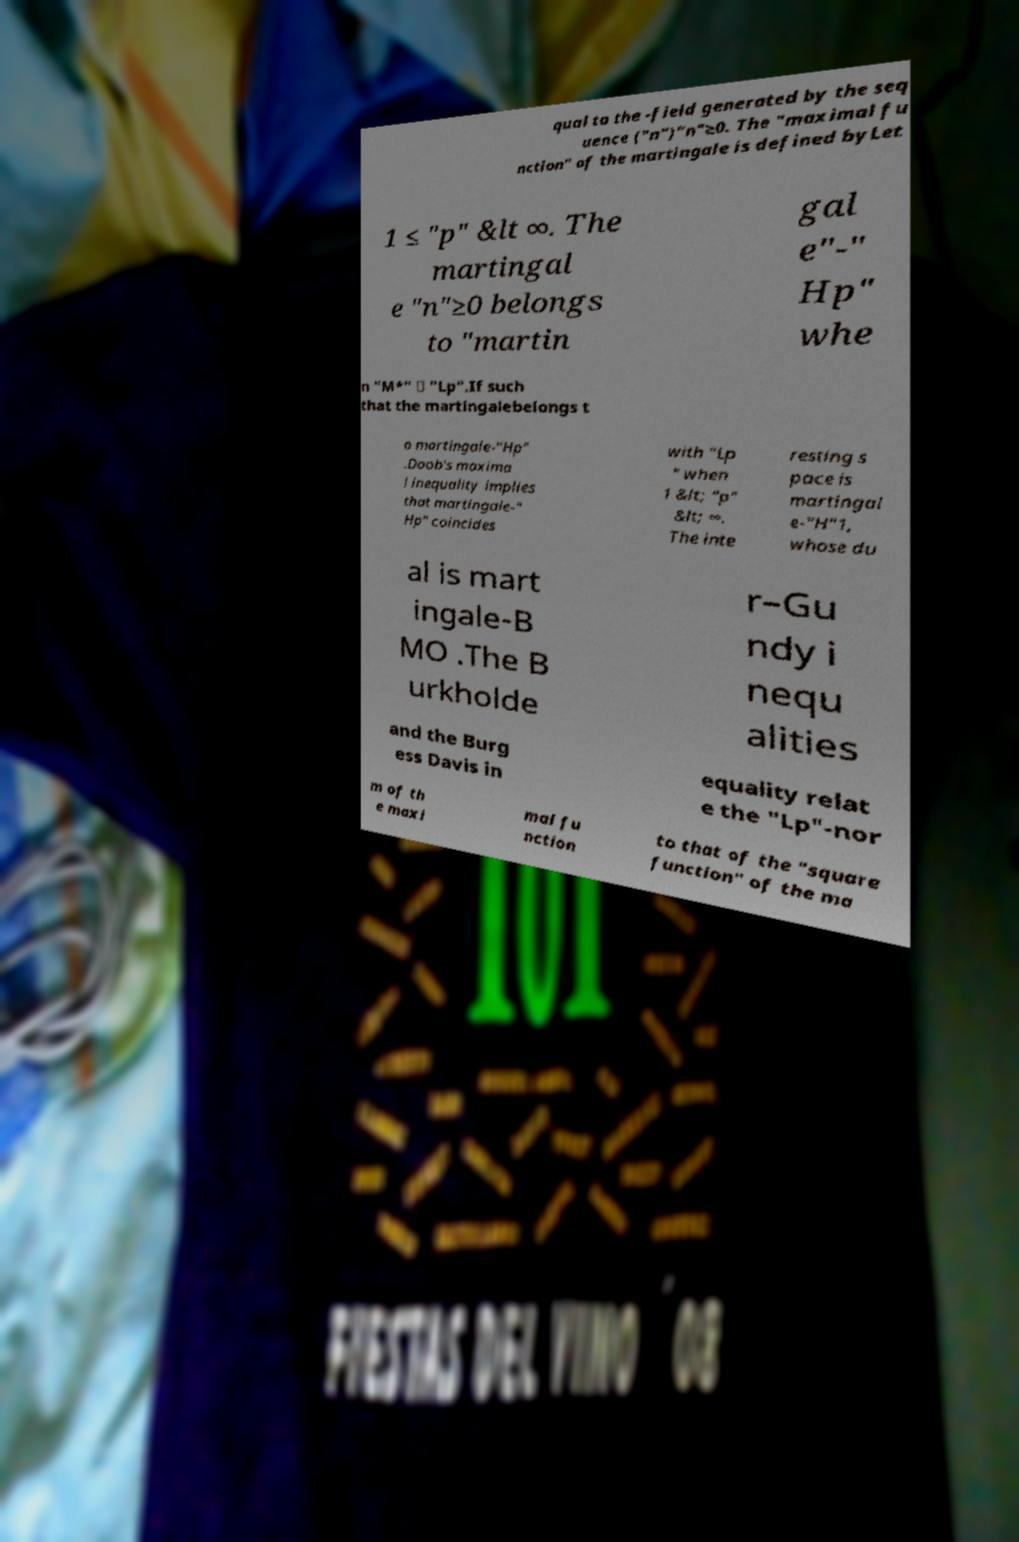Could you assist in decoding the text presented in this image and type it out clearly? qual to the -field generated by the seq uence ("n")"n"≥0. The "maximal fu nction" of the martingale is defined byLet 1 ≤ "p" &lt ∞. The martingal e "n"≥0 belongs to "martin gal e"-" Hp" whe n "M*" ∈ "Lp".If such that the martingalebelongs t o martingale-"Hp" .Doob's maxima l inequality implies that martingale-" Hp" coincides with "Lp " when 1 &lt; "p" &lt; ∞. The inte resting s pace is martingal e-"H"1, whose du al is mart ingale-B MO .The B urkholde r–Gu ndy i nequ alities and the Burg ess Davis in equality relat e the "Lp"-nor m of th e maxi mal fu nction to that of the "square function" of the ma 